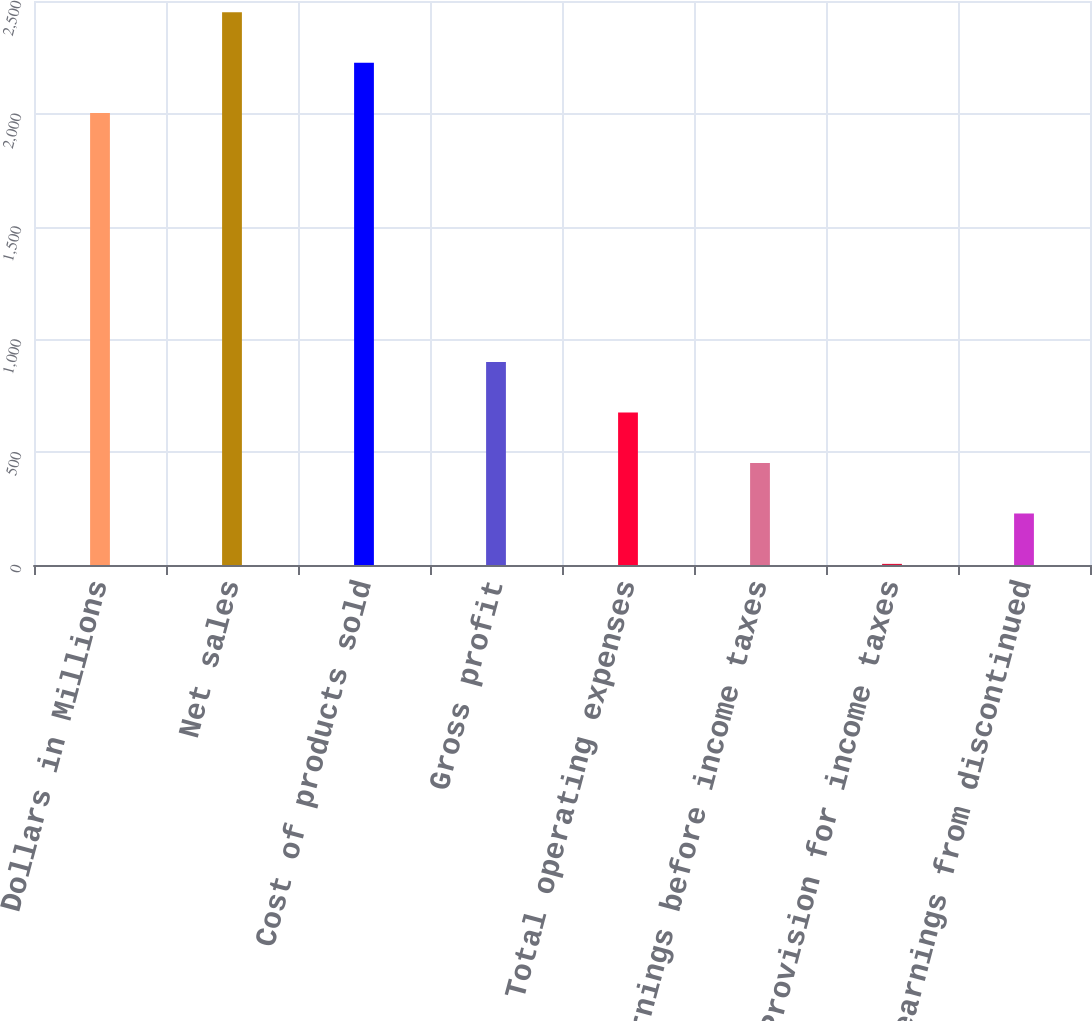<chart> <loc_0><loc_0><loc_500><loc_500><bar_chart><fcel>Dollars in Millions<fcel>Net sales<fcel>Cost of products sold<fcel>Gross profit<fcel>Total operating expenses<fcel>Earnings before income taxes<fcel>Provision for income taxes<fcel>Net earnings from discontinued<nl><fcel>2003<fcel>2450.2<fcel>2226.6<fcel>899.4<fcel>675.8<fcel>452.2<fcel>5<fcel>228.6<nl></chart> 